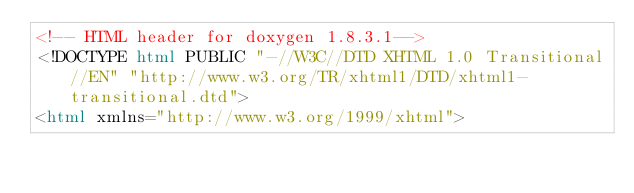<code> <loc_0><loc_0><loc_500><loc_500><_HTML_><!-- HTML header for doxygen 1.8.3.1-->
<!DOCTYPE html PUBLIC "-//W3C//DTD XHTML 1.0 Transitional//EN" "http://www.w3.org/TR/xhtml1/DTD/xhtml1-transitional.dtd">
<html xmlns="http://www.w3.org/1999/xhtml"></code> 